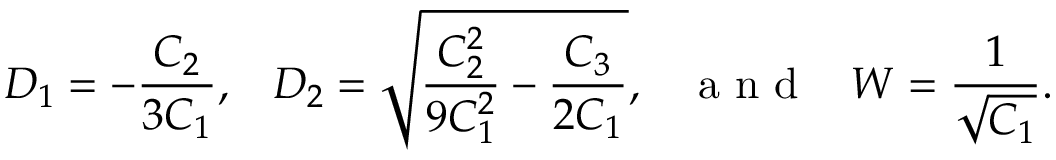Convert formula to latex. <formula><loc_0><loc_0><loc_500><loc_500>D _ { 1 } = - \frac { C _ { 2 } } { 3 C _ { 1 } } , \, D _ { 2 } = \sqrt { \frac { C _ { 2 } ^ { 2 } } { 9 C _ { 1 } ^ { 2 } } - \frac { C _ { 3 } } { 2 C _ { 1 } } } , \, a n d \, W = \frac { 1 } { \sqrt { C _ { 1 } } } .</formula> 